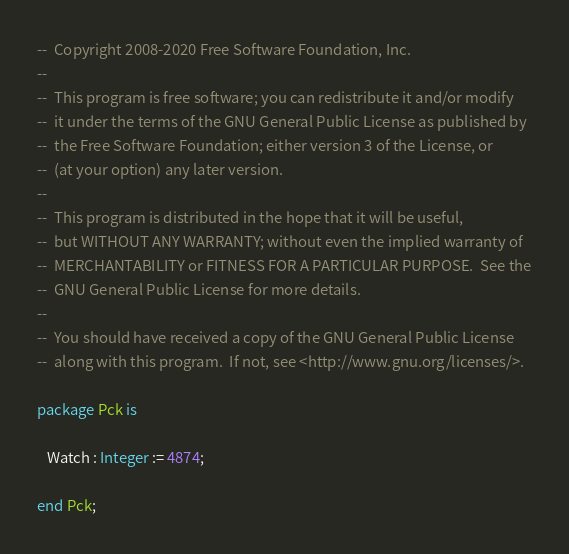Convert code to text. <code><loc_0><loc_0><loc_500><loc_500><_Ada_>--  Copyright 2008-2020 Free Software Foundation, Inc.
--
--  This program is free software; you can redistribute it and/or modify
--  it under the terms of the GNU General Public License as published by
--  the Free Software Foundation; either version 3 of the License, or
--  (at your option) any later version.
--
--  This program is distributed in the hope that it will be useful,
--  but WITHOUT ANY WARRANTY; without even the implied warranty of
--  MERCHANTABILITY or FITNESS FOR A PARTICULAR PURPOSE.  See the
--  GNU General Public License for more details.
--
--  You should have received a copy of the GNU General Public License
--  along with this program.  If not, see <http://www.gnu.org/licenses/>.

package Pck is

   Watch : Integer := 4874;

end Pck;
</code> 